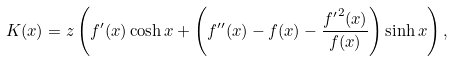<formula> <loc_0><loc_0><loc_500><loc_500>K ( x ) = z \left ( f ^ { \prime } ( x ) \cosh x + \left ( f ^ { \prime \prime } ( x ) - f ( x ) - \frac { { f ^ { \prime } } ^ { 2 } ( x ) } { f ( x ) } \right ) \sinh x \right ) ,</formula> 